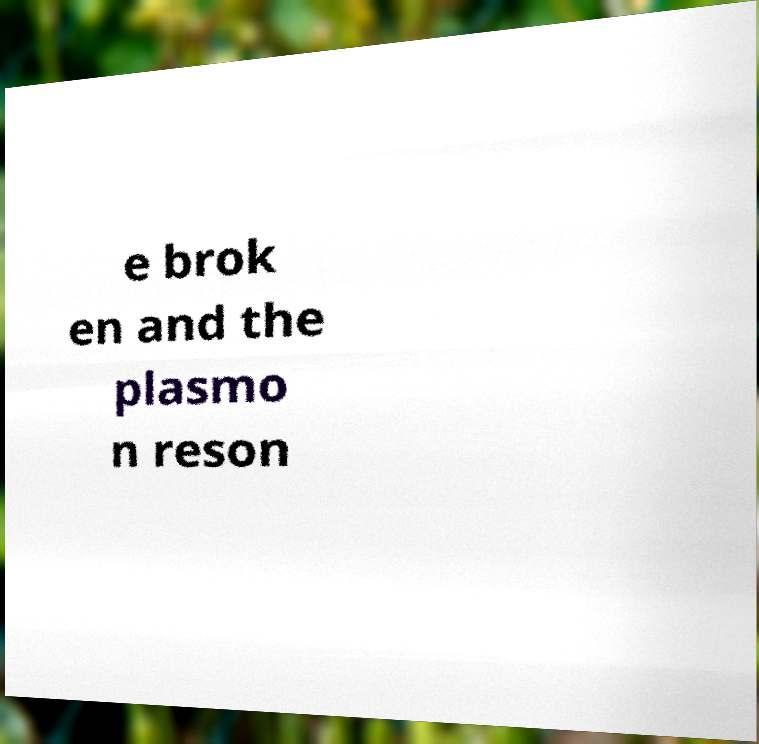Can you read and provide the text displayed in the image?This photo seems to have some interesting text. Can you extract and type it out for me? e brok en and the plasmo n reson 